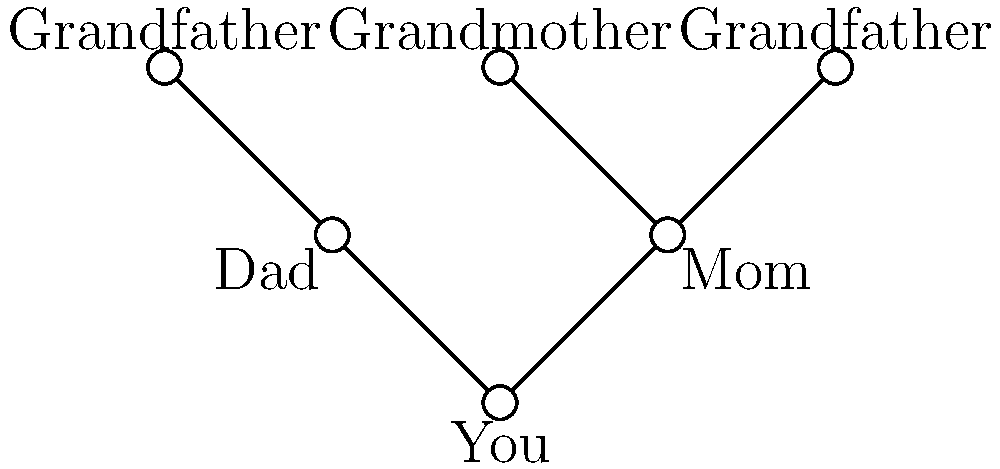In creating a family tree diagram to visualize genealogical relationships, you want to represent your immediate family members. Given the graph above, what is the minimum number of edges needed to connect all the vertices (family members) in the diagram? To find the minimum number of edges needed to connect all vertices in the family tree diagram, we need to identify the minimum spanning tree of the graph. Here's a step-by-step approach:

1. Count the total number of vertices (family members) in the diagram:
   There are 6 vertices representing You, Mom, Dad, Grandmother, and two Grandfathers.

2. Recall that in a tree, the number of edges is always one less than the number of vertices. This is because a tree is a connected graph with no cycles.

3. Apply the formula for the number of edges in a tree:
   Number of edges = Number of vertices - 1

4. Calculate:
   Number of edges = 6 - 1 = 5

Therefore, the minimum number of edges needed to connect all family members in the diagram is 5. This creates a tree structure that represents the family relationships without any redundant connections.
Answer: 5 edges 